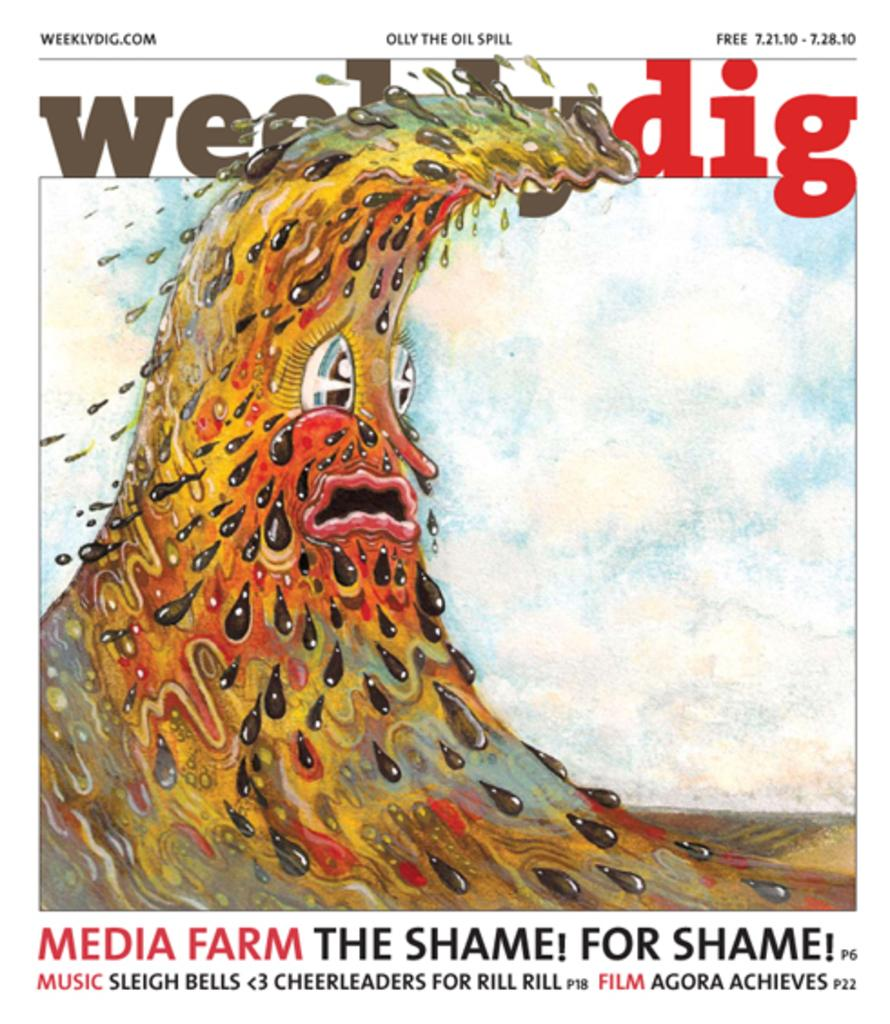What is the main subject in the center of the image? There is a poster in the center of the image. What type of artwork is visible in the image? There is some painting in the image. Where can text be found in the image? Text can be found at the top and bottom of the image. What type of plate is being used as a canvas for the painting in the image? There is no plate present in the image; the painting is not on a plate. 